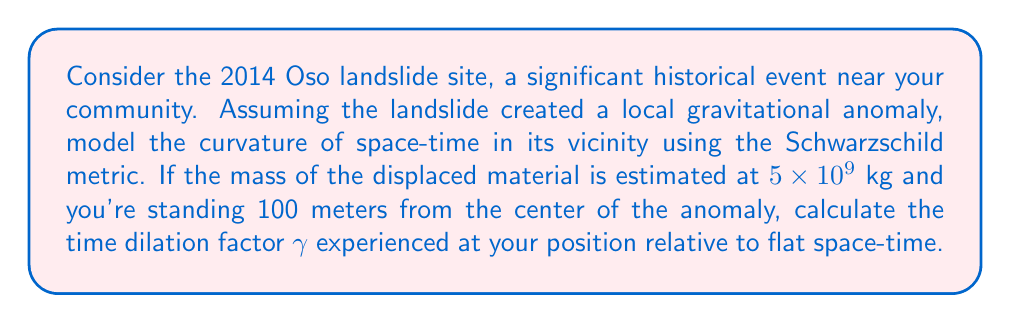Provide a solution to this math problem. 1) The Schwarzschild metric describes the curvature of space-time near a spherically symmetric mass. The time dilation factor $\gamma$ is given by:

   $$\gamma = \sqrt{1 - \frac{2GM}{rc^2}}$$

   Where:
   - $G$ is the gravitational constant: $6.674 \times 10^{-11} \text{ m}^3 \text{ kg}^{-1} \text{ s}^{-2}$
   - $M$ is the mass of the object (in this case, the landslide material)
   - $r$ is the distance from the center of the mass
   - $c$ is the speed of light: $2.998 \times 10^8 \text{ m/s}$

2) Let's substitute our known values:
   - $M = 5 \times 10^9 \text{ kg}$
   - $r = 100 \text{ m}$

3) Now, let's calculate:

   $$\gamma = \sqrt{1 - \frac{2 \cdot (6.674 \times 10^{-11}) \cdot (5 \times 10^9)}{100 \cdot (2.998 \times 10^8)^2}}$$

4) Simplify:
   $$\gamma = \sqrt{1 - \frac{6.674 \times 10^{-1}}{8.988 \times 10^{17}}}$$

5) Evaluate:
   $$\gamma = \sqrt{1 - 7.425 \times 10^{-19}}$$

6) The square root of a number very close to 1 can be approximated as 1 minus half the small difference:
   $$\gamma \approx 1 - \frac{1}{2}(7.425 \times 10^{-19}) = 1 - 3.713 \times 10^{-19}$$
Answer: $\gamma \approx 1 - 3.713 \times 10^{-19}$ 